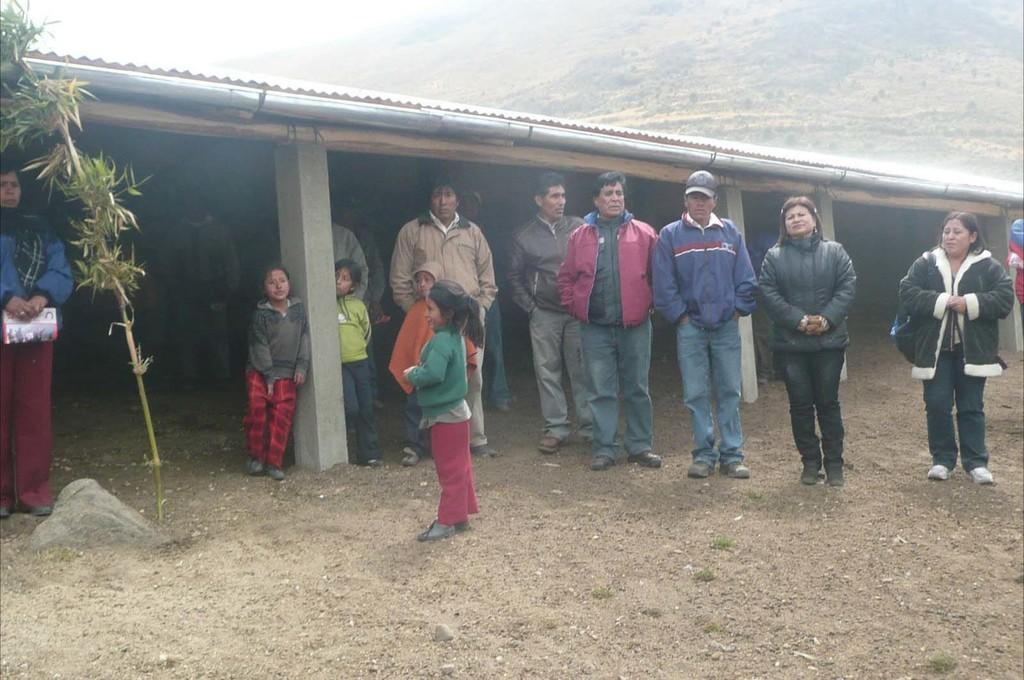How many people are in the image? There is a group of people in the image, but the exact number is not specified. What are the people in the image doing? The people are standing in the image. What type of clothing are the people wearing? The people are wearing jackets and footwear in the image. What can be seen in the background of the image? There are pillars, a roof, a hill, plants, and the sky visible in the background of the image. What type of arithmetic problem is being solved by the people in the image? There is no indication in the image that the people are solving an arithmetic problem. What shape is the hill in the image? The shape of the hill is not specified in the image. 